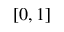<formula> <loc_0><loc_0><loc_500><loc_500>[ 0 , 1 ]</formula> 